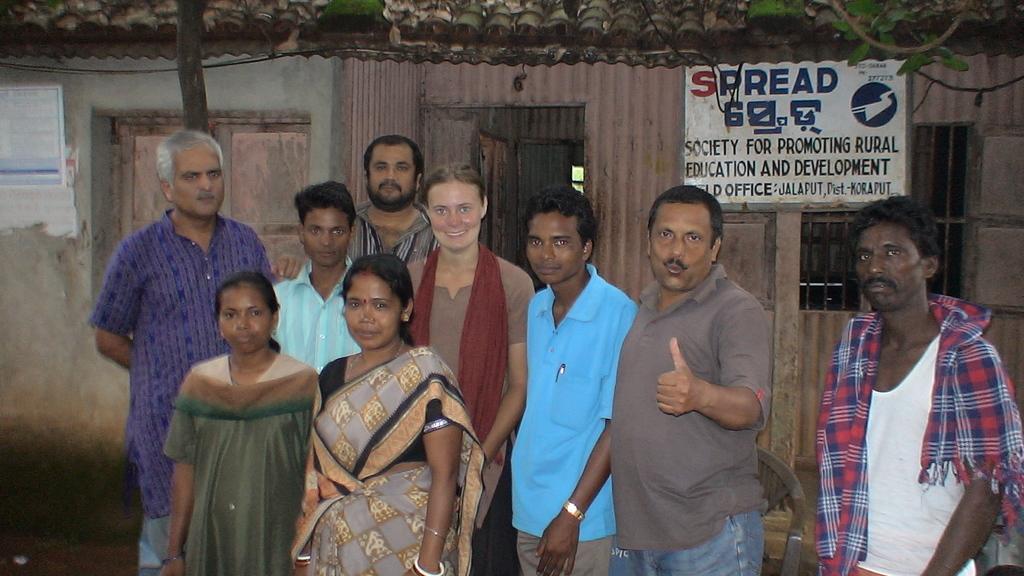Describe this image in one or two sentences. In this picture we can see there is a group of people standing and behind the people there is a house with a board. In front of the house there are cables and a branch. 